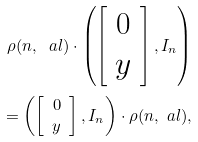<formula> <loc_0><loc_0><loc_500><loc_500>\rho ( n , \ a l ) \cdot \left ( \left [ \begin{array} { c } 0 \\ y \end{array} \right ] , I _ { n } \right ) \\ = \left ( \left [ \begin{array} { c } 0 \\ y \end{array} \right ] , I _ { n } \right ) \cdot \rho ( n , \ a l ) ,</formula> 